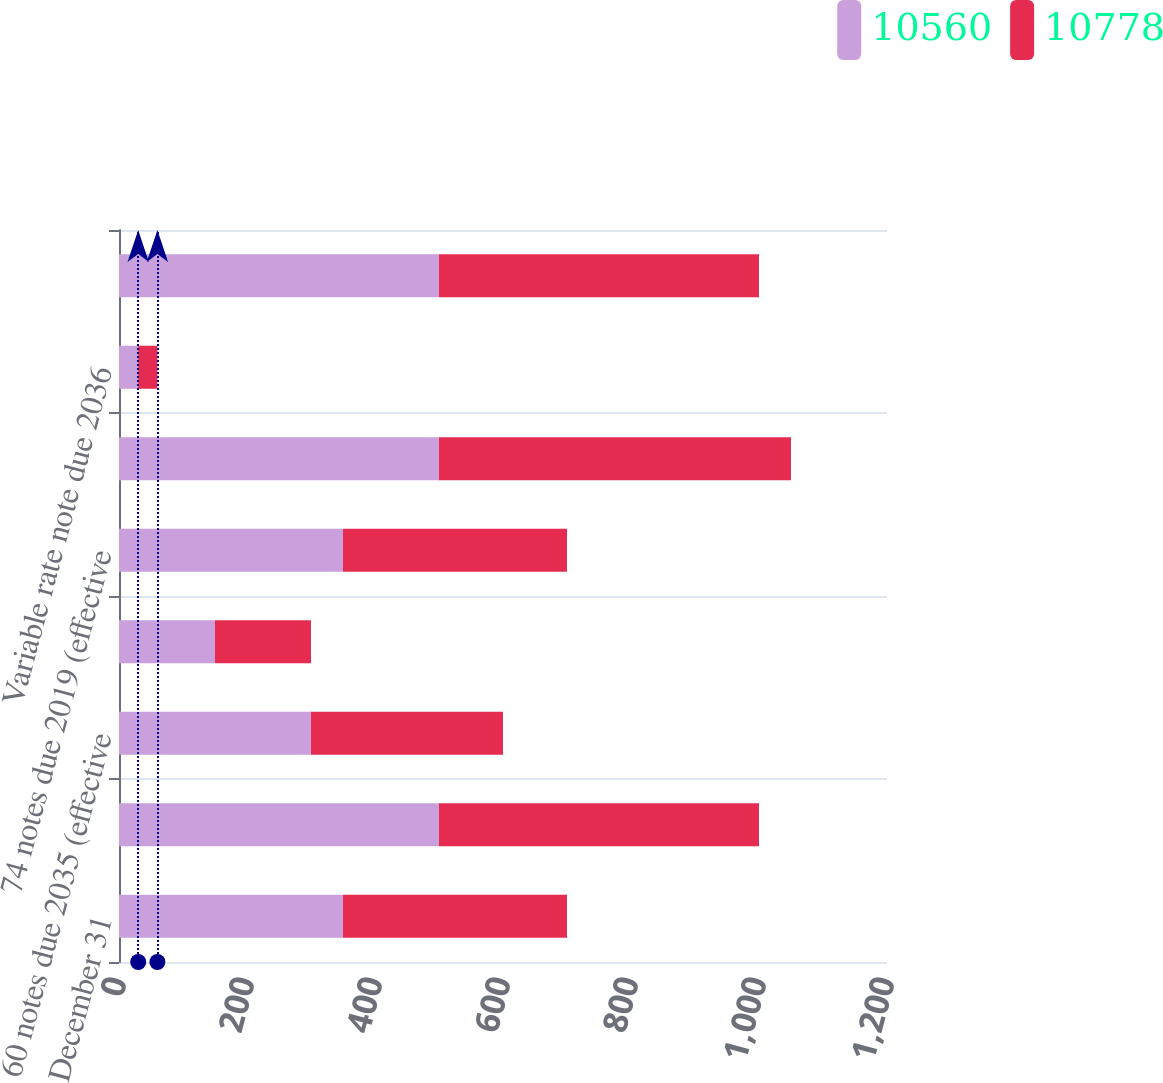Convert chart to OTSL. <chart><loc_0><loc_0><loc_500><loc_500><stacked_bar_chart><ecel><fcel>December 31<fcel>26 notes due 2023 (effective<fcel>60 notes due 2035 (effective<fcel>70 notes due 2018 (effective<fcel>74 notes due 2019 (effective<fcel>45 notes due 2026 (effective<fcel>Variable rate note due 2036<fcel>59 notes due 2019 (effective<nl><fcel>10560<fcel>350<fcel>500<fcel>300<fcel>150<fcel>350<fcel>500<fcel>30<fcel>500<nl><fcel>10778<fcel>350<fcel>500<fcel>300<fcel>150<fcel>350<fcel>550<fcel>30<fcel>500<nl></chart> 